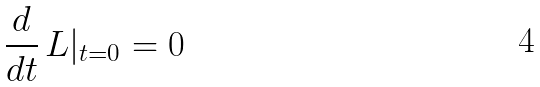<formula> <loc_0><loc_0><loc_500><loc_500>\frac { d } { d t } \, L | _ { t = 0 } = 0</formula> 